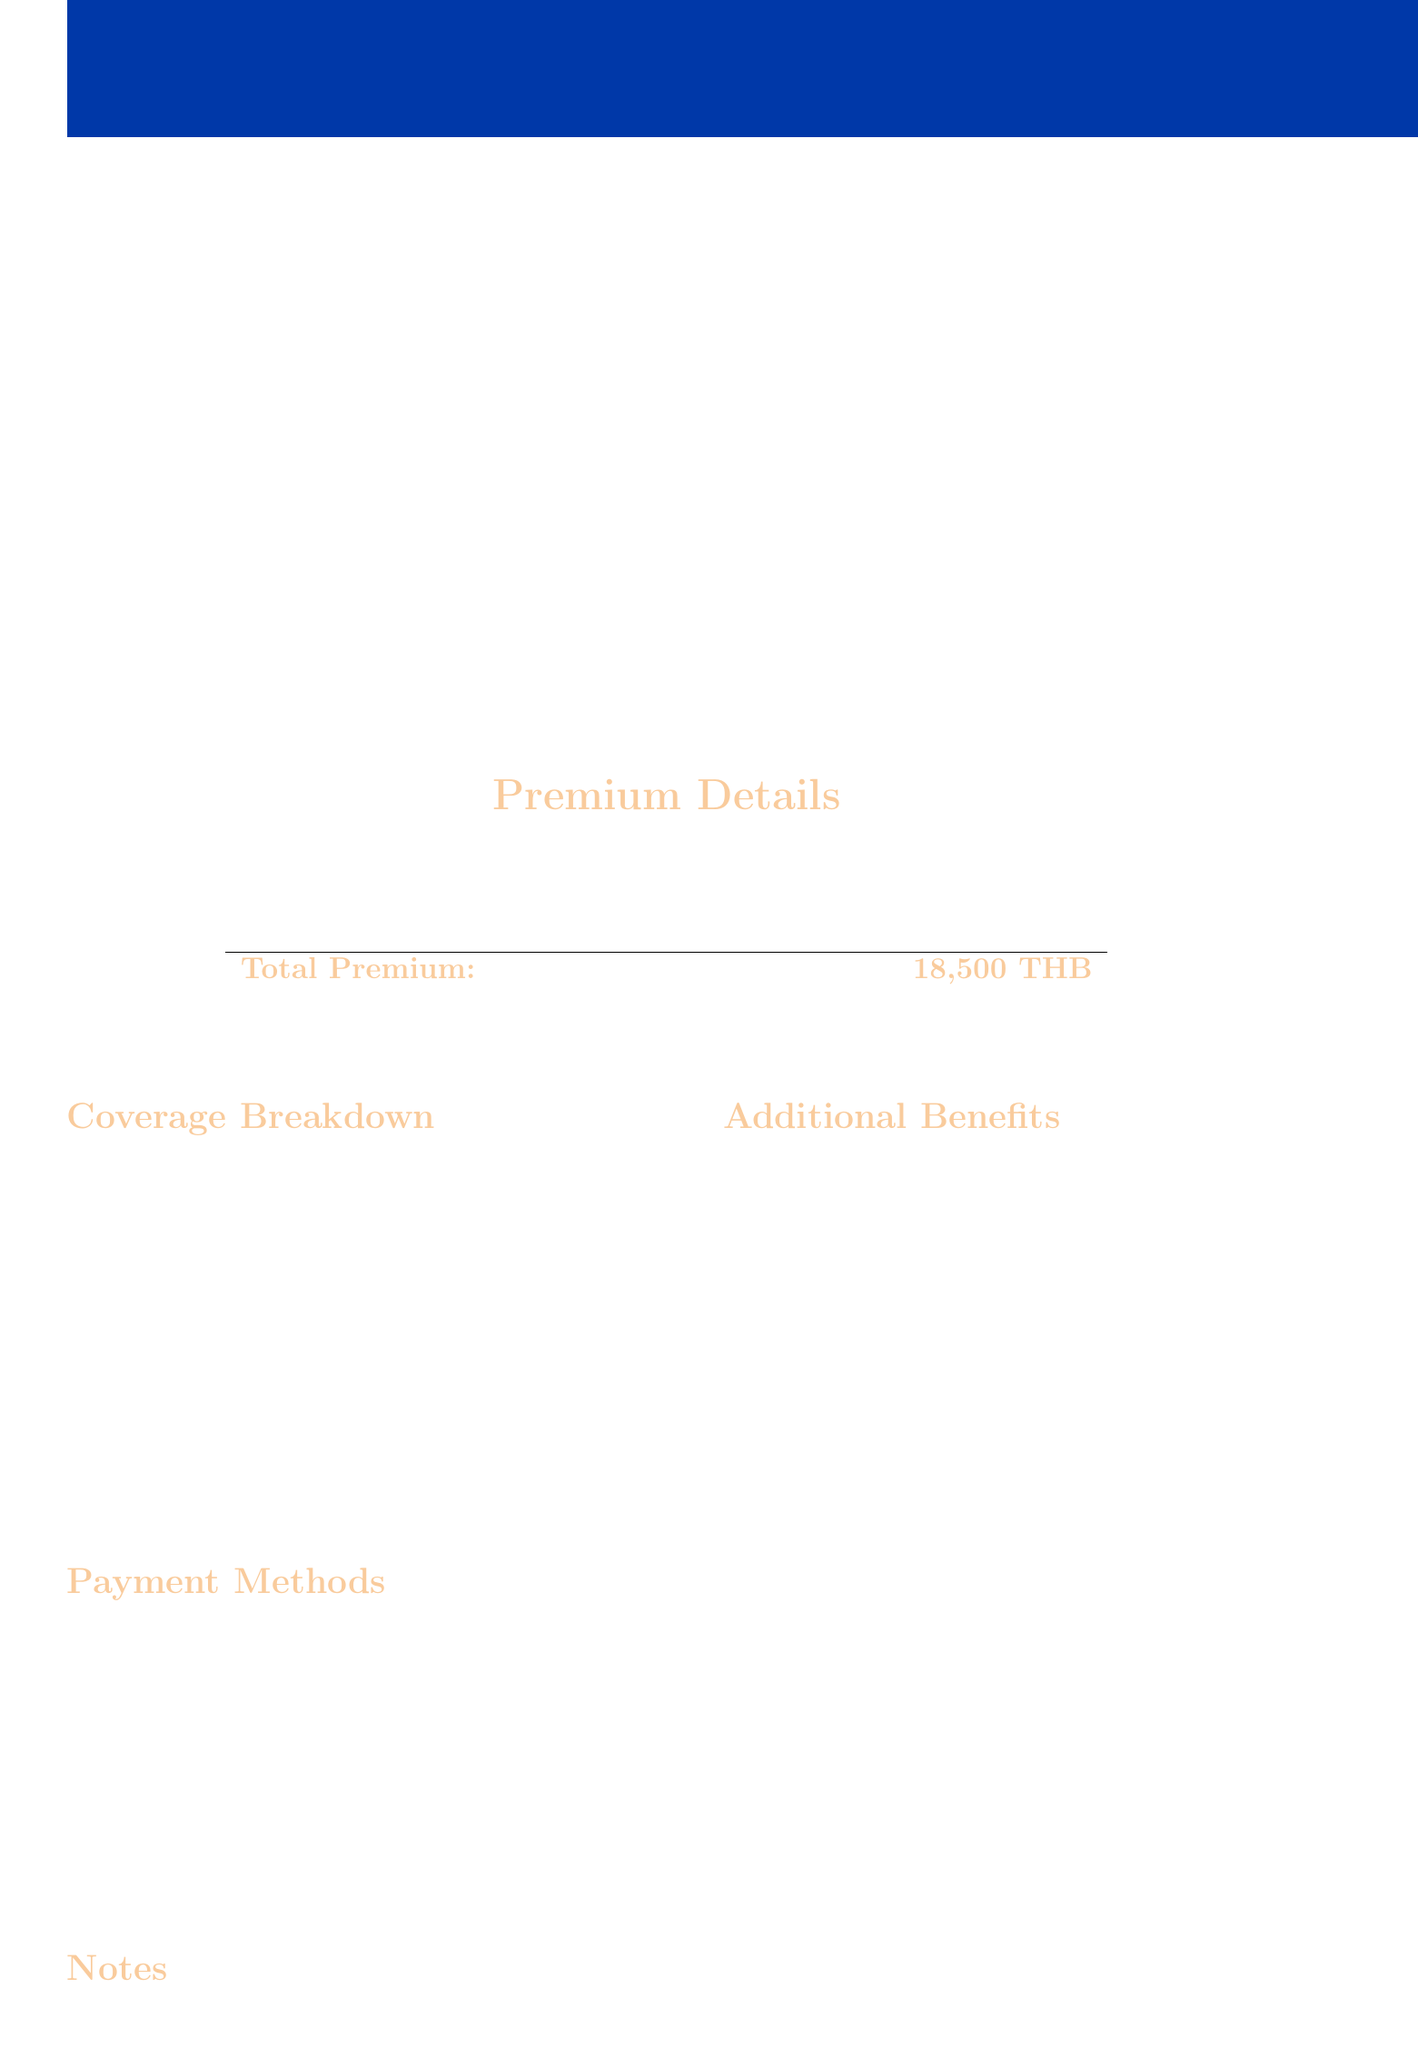What is the invoice number? The invoice number is a specific identifier provided in the document.
Answer: INS-2023-Q2-0042 What is the due date for payment? The due date is specified for when the payment should be made.
Answer: 2023-07-15 Who is the insured person? The insured person is the individual who is covered by the insurance policy listed in the document.
Answer: Somchai Jaidee What is the total premium amount? The total premium is calculated by summing the base premium and additional coverage premium.
Answer: 18500 THB What is the limit for emergency medical evacuation? The limit for emergency medical evacuation coverage is provided in the breakdown section.
Answer: 2000000 THB What additional benefit includes counseling services? This benefit refers to the mental health support provided in the policy.
Answer: Mental Health Support What is the base premium amount? The base premium amount is explicitly stated in the premium details section of the document.
Answer: 15000 THB Which payment method allows for mobile banking? The document outlines several payment methods, one of which is specifically for mobile banking.
Answer: Mobile Banking What is the purpose of this insurance plan? The document states the specific group this plan is designed for.
Answer: International teachers working in Thailand 